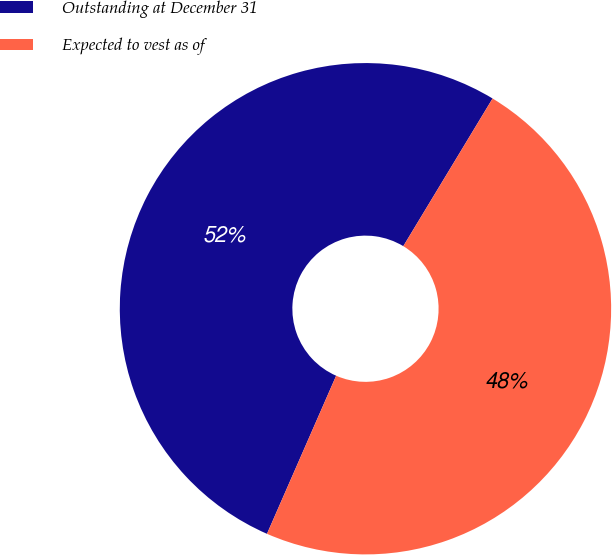Convert chart to OTSL. <chart><loc_0><loc_0><loc_500><loc_500><pie_chart><fcel>Outstanding at December 31<fcel>Expected to vest as of<nl><fcel>52.09%<fcel>47.91%<nl></chart> 